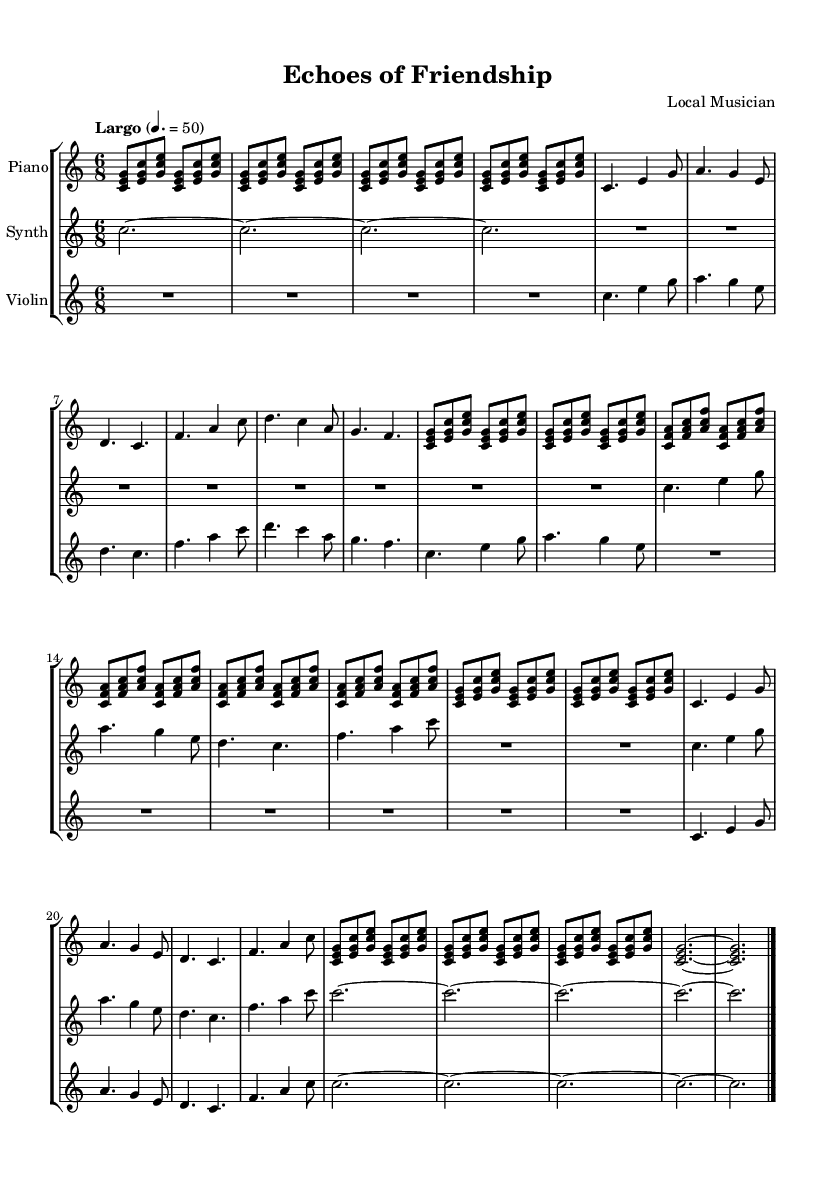What is the key signature of this music? The key signature is defined at the beginning of the score, indicated by the "c" below "key". C major has no sharps or flats.
Answer: C major What is the time signature of this music? The time signature can be found at the start of the score, shown as "6/8". This means there are six eighth notes per measure.
Answer: 6/8 What tempo is indicated for this piece? The tempo marking is shown as "Largo" with a metronome marking of 4 = 50. Largo indicates a slow tempo.
Answer: Largo, 50 How many measures are in Section A? By counting the individual measures indicated within the section marked as "Section A", we see there are six measures in this section.
Answer: 6 What are the three instruments used in this piece? The instruments are listed at the beginning of the score. They include "Piano", "Synth", and "Violin".
Answer: Piano, Synth, Violin How does the violin part differ between Section A and Section B? In Section A, the violin has active melodic contributions with rhythm and pitch variations, while in Section B, the violin part consists of rests, showing a contrast in activity.
Answer: More active in Section A What is the overall mood created by the tempo and dynamics in this piece? The slow tempo of "Largo" combined with the soft dynamics represented creates a serene and introspective mood, more commonly found in ambient works.
Answer: Serene, introspective 